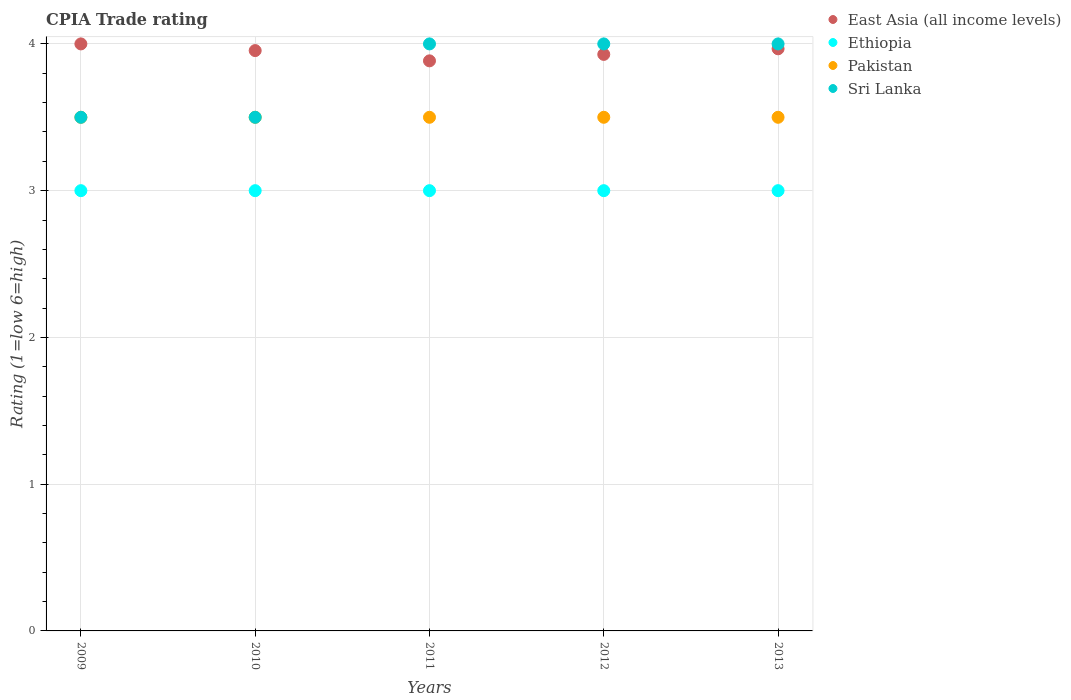Is the number of dotlines equal to the number of legend labels?
Offer a very short reply. Yes. Across all years, what is the maximum CPIA rating in Sri Lanka?
Provide a succinct answer. 4. Across all years, what is the minimum CPIA rating in East Asia (all income levels)?
Make the answer very short. 3.88. In which year was the CPIA rating in Pakistan minimum?
Provide a short and direct response. 2009. What is the total CPIA rating in East Asia (all income levels) in the graph?
Keep it short and to the point. 19.73. What is the difference between the CPIA rating in East Asia (all income levels) in 2010 and that in 2013?
Your answer should be very brief. -0.01. What is the difference between the CPIA rating in Pakistan in 2010 and the CPIA rating in Ethiopia in 2009?
Make the answer very short. 0.5. In the year 2012, what is the difference between the CPIA rating in Pakistan and CPIA rating in Sri Lanka?
Offer a very short reply. -0.5. In how many years, is the CPIA rating in East Asia (all income levels) greater than 1.2?
Provide a succinct answer. 5. What is the ratio of the CPIA rating in Ethiopia in 2010 to that in 2011?
Offer a terse response. 1. Is the CPIA rating in Ethiopia in 2012 less than that in 2013?
Give a very brief answer. No. What is the difference between the highest and the second highest CPIA rating in Sri Lanka?
Offer a terse response. 0. Is it the case that in every year, the sum of the CPIA rating in Ethiopia and CPIA rating in Pakistan  is greater than the sum of CPIA rating in East Asia (all income levels) and CPIA rating in Sri Lanka?
Your answer should be compact. No. Is it the case that in every year, the sum of the CPIA rating in Ethiopia and CPIA rating in East Asia (all income levels)  is greater than the CPIA rating in Sri Lanka?
Make the answer very short. Yes. Is the CPIA rating in Pakistan strictly greater than the CPIA rating in Ethiopia over the years?
Provide a succinct answer. Yes. Is the CPIA rating in East Asia (all income levels) strictly less than the CPIA rating in Pakistan over the years?
Ensure brevity in your answer.  No. How many years are there in the graph?
Ensure brevity in your answer.  5. Are the values on the major ticks of Y-axis written in scientific E-notation?
Offer a very short reply. No. Does the graph contain any zero values?
Offer a terse response. No. Does the graph contain grids?
Offer a terse response. Yes. Where does the legend appear in the graph?
Offer a terse response. Top right. What is the title of the graph?
Keep it short and to the point. CPIA Trade rating. What is the label or title of the X-axis?
Your response must be concise. Years. What is the Rating (1=low 6=high) of East Asia (all income levels) in 2009?
Provide a succinct answer. 4. What is the Rating (1=low 6=high) of Ethiopia in 2009?
Keep it short and to the point. 3. What is the Rating (1=low 6=high) of Pakistan in 2009?
Offer a very short reply. 3.5. What is the Rating (1=low 6=high) in East Asia (all income levels) in 2010?
Provide a succinct answer. 3.95. What is the Rating (1=low 6=high) in Ethiopia in 2010?
Keep it short and to the point. 3. What is the Rating (1=low 6=high) in Pakistan in 2010?
Provide a short and direct response. 3.5. What is the Rating (1=low 6=high) of Sri Lanka in 2010?
Provide a short and direct response. 3.5. What is the Rating (1=low 6=high) in East Asia (all income levels) in 2011?
Keep it short and to the point. 3.88. What is the Rating (1=low 6=high) of Pakistan in 2011?
Give a very brief answer. 3.5. What is the Rating (1=low 6=high) in East Asia (all income levels) in 2012?
Provide a short and direct response. 3.93. What is the Rating (1=low 6=high) of Ethiopia in 2012?
Give a very brief answer. 3. What is the Rating (1=low 6=high) in Sri Lanka in 2012?
Ensure brevity in your answer.  4. What is the Rating (1=low 6=high) in East Asia (all income levels) in 2013?
Offer a very short reply. 3.97. What is the Rating (1=low 6=high) in Ethiopia in 2013?
Give a very brief answer. 3. Across all years, what is the maximum Rating (1=low 6=high) in Ethiopia?
Your response must be concise. 3. Across all years, what is the maximum Rating (1=low 6=high) of Pakistan?
Provide a short and direct response. 3.5. Across all years, what is the minimum Rating (1=low 6=high) of East Asia (all income levels)?
Give a very brief answer. 3.88. Across all years, what is the minimum Rating (1=low 6=high) of Ethiopia?
Keep it short and to the point. 3. What is the total Rating (1=low 6=high) of East Asia (all income levels) in the graph?
Offer a terse response. 19.73. What is the total Rating (1=low 6=high) in Pakistan in the graph?
Offer a terse response. 17.5. What is the total Rating (1=low 6=high) of Sri Lanka in the graph?
Offer a very short reply. 19. What is the difference between the Rating (1=low 6=high) in East Asia (all income levels) in 2009 and that in 2010?
Give a very brief answer. 0.05. What is the difference between the Rating (1=low 6=high) of Ethiopia in 2009 and that in 2010?
Your answer should be compact. 0. What is the difference between the Rating (1=low 6=high) of Pakistan in 2009 and that in 2010?
Provide a short and direct response. 0. What is the difference between the Rating (1=low 6=high) in Sri Lanka in 2009 and that in 2010?
Ensure brevity in your answer.  0. What is the difference between the Rating (1=low 6=high) of East Asia (all income levels) in 2009 and that in 2011?
Provide a succinct answer. 0.12. What is the difference between the Rating (1=low 6=high) in Pakistan in 2009 and that in 2011?
Your answer should be very brief. 0. What is the difference between the Rating (1=low 6=high) of East Asia (all income levels) in 2009 and that in 2012?
Your response must be concise. 0.07. What is the difference between the Rating (1=low 6=high) in Sri Lanka in 2009 and that in 2012?
Give a very brief answer. -0.5. What is the difference between the Rating (1=low 6=high) in Ethiopia in 2009 and that in 2013?
Make the answer very short. 0. What is the difference between the Rating (1=low 6=high) of Pakistan in 2009 and that in 2013?
Your answer should be very brief. 0. What is the difference between the Rating (1=low 6=high) in East Asia (all income levels) in 2010 and that in 2011?
Your answer should be compact. 0.07. What is the difference between the Rating (1=low 6=high) of Ethiopia in 2010 and that in 2011?
Your response must be concise. 0. What is the difference between the Rating (1=low 6=high) in East Asia (all income levels) in 2010 and that in 2012?
Your answer should be compact. 0.03. What is the difference between the Rating (1=low 6=high) in Ethiopia in 2010 and that in 2012?
Provide a succinct answer. 0. What is the difference between the Rating (1=low 6=high) of Pakistan in 2010 and that in 2012?
Ensure brevity in your answer.  0. What is the difference between the Rating (1=low 6=high) of East Asia (all income levels) in 2010 and that in 2013?
Offer a terse response. -0.01. What is the difference between the Rating (1=low 6=high) of Pakistan in 2010 and that in 2013?
Provide a short and direct response. 0. What is the difference between the Rating (1=low 6=high) of East Asia (all income levels) in 2011 and that in 2012?
Your answer should be very brief. -0.04. What is the difference between the Rating (1=low 6=high) of Pakistan in 2011 and that in 2012?
Ensure brevity in your answer.  0. What is the difference between the Rating (1=low 6=high) in Sri Lanka in 2011 and that in 2012?
Give a very brief answer. 0. What is the difference between the Rating (1=low 6=high) in East Asia (all income levels) in 2011 and that in 2013?
Provide a succinct answer. -0.08. What is the difference between the Rating (1=low 6=high) of East Asia (all income levels) in 2012 and that in 2013?
Offer a terse response. -0.04. What is the difference between the Rating (1=low 6=high) of Pakistan in 2012 and that in 2013?
Keep it short and to the point. 0. What is the difference between the Rating (1=low 6=high) in Sri Lanka in 2012 and that in 2013?
Provide a short and direct response. 0. What is the difference between the Rating (1=low 6=high) in East Asia (all income levels) in 2009 and the Rating (1=low 6=high) in Ethiopia in 2010?
Provide a short and direct response. 1. What is the difference between the Rating (1=low 6=high) of East Asia (all income levels) in 2009 and the Rating (1=low 6=high) of Pakistan in 2010?
Make the answer very short. 0.5. What is the difference between the Rating (1=low 6=high) of Ethiopia in 2009 and the Rating (1=low 6=high) of Sri Lanka in 2010?
Provide a short and direct response. -0.5. What is the difference between the Rating (1=low 6=high) of Pakistan in 2009 and the Rating (1=low 6=high) of Sri Lanka in 2010?
Offer a very short reply. 0. What is the difference between the Rating (1=low 6=high) in Ethiopia in 2009 and the Rating (1=low 6=high) in Sri Lanka in 2011?
Give a very brief answer. -1. What is the difference between the Rating (1=low 6=high) of Pakistan in 2009 and the Rating (1=low 6=high) of Sri Lanka in 2011?
Offer a terse response. -0.5. What is the difference between the Rating (1=low 6=high) of Ethiopia in 2009 and the Rating (1=low 6=high) of Pakistan in 2012?
Ensure brevity in your answer.  -0.5. What is the difference between the Rating (1=low 6=high) of Ethiopia in 2009 and the Rating (1=low 6=high) of Sri Lanka in 2012?
Provide a short and direct response. -1. What is the difference between the Rating (1=low 6=high) in Pakistan in 2009 and the Rating (1=low 6=high) in Sri Lanka in 2012?
Make the answer very short. -0.5. What is the difference between the Rating (1=low 6=high) of East Asia (all income levels) in 2009 and the Rating (1=low 6=high) of Ethiopia in 2013?
Your response must be concise. 1. What is the difference between the Rating (1=low 6=high) in East Asia (all income levels) in 2009 and the Rating (1=low 6=high) in Pakistan in 2013?
Ensure brevity in your answer.  0.5. What is the difference between the Rating (1=low 6=high) in East Asia (all income levels) in 2009 and the Rating (1=low 6=high) in Sri Lanka in 2013?
Your answer should be very brief. 0. What is the difference between the Rating (1=low 6=high) of East Asia (all income levels) in 2010 and the Rating (1=low 6=high) of Ethiopia in 2011?
Offer a terse response. 0.95. What is the difference between the Rating (1=low 6=high) of East Asia (all income levels) in 2010 and the Rating (1=low 6=high) of Pakistan in 2011?
Keep it short and to the point. 0.45. What is the difference between the Rating (1=low 6=high) of East Asia (all income levels) in 2010 and the Rating (1=low 6=high) of Sri Lanka in 2011?
Make the answer very short. -0.05. What is the difference between the Rating (1=low 6=high) in Ethiopia in 2010 and the Rating (1=low 6=high) in Pakistan in 2011?
Offer a very short reply. -0.5. What is the difference between the Rating (1=low 6=high) of East Asia (all income levels) in 2010 and the Rating (1=low 6=high) of Ethiopia in 2012?
Your response must be concise. 0.95. What is the difference between the Rating (1=low 6=high) of East Asia (all income levels) in 2010 and the Rating (1=low 6=high) of Pakistan in 2012?
Your response must be concise. 0.45. What is the difference between the Rating (1=low 6=high) of East Asia (all income levels) in 2010 and the Rating (1=low 6=high) of Sri Lanka in 2012?
Offer a terse response. -0.05. What is the difference between the Rating (1=low 6=high) of Ethiopia in 2010 and the Rating (1=low 6=high) of Sri Lanka in 2012?
Give a very brief answer. -1. What is the difference between the Rating (1=low 6=high) of Pakistan in 2010 and the Rating (1=low 6=high) of Sri Lanka in 2012?
Ensure brevity in your answer.  -0.5. What is the difference between the Rating (1=low 6=high) in East Asia (all income levels) in 2010 and the Rating (1=low 6=high) in Ethiopia in 2013?
Offer a very short reply. 0.95. What is the difference between the Rating (1=low 6=high) in East Asia (all income levels) in 2010 and the Rating (1=low 6=high) in Pakistan in 2013?
Your response must be concise. 0.45. What is the difference between the Rating (1=low 6=high) of East Asia (all income levels) in 2010 and the Rating (1=low 6=high) of Sri Lanka in 2013?
Give a very brief answer. -0.05. What is the difference between the Rating (1=low 6=high) of Ethiopia in 2010 and the Rating (1=low 6=high) of Sri Lanka in 2013?
Ensure brevity in your answer.  -1. What is the difference between the Rating (1=low 6=high) of East Asia (all income levels) in 2011 and the Rating (1=low 6=high) of Ethiopia in 2012?
Keep it short and to the point. 0.88. What is the difference between the Rating (1=low 6=high) in East Asia (all income levels) in 2011 and the Rating (1=low 6=high) in Pakistan in 2012?
Keep it short and to the point. 0.38. What is the difference between the Rating (1=low 6=high) in East Asia (all income levels) in 2011 and the Rating (1=low 6=high) in Sri Lanka in 2012?
Make the answer very short. -0.12. What is the difference between the Rating (1=low 6=high) of East Asia (all income levels) in 2011 and the Rating (1=low 6=high) of Ethiopia in 2013?
Provide a short and direct response. 0.88. What is the difference between the Rating (1=low 6=high) in East Asia (all income levels) in 2011 and the Rating (1=low 6=high) in Pakistan in 2013?
Provide a succinct answer. 0.38. What is the difference between the Rating (1=low 6=high) in East Asia (all income levels) in 2011 and the Rating (1=low 6=high) in Sri Lanka in 2013?
Your answer should be compact. -0.12. What is the difference between the Rating (1=low 6=high) of Ethiopia in 2011 and the Rating (1=low 6=high) of Pakistan in 2013?
Offer a very short reply. -0.5. What is the difference between the Rating (1=low 6=high) in Ethiopia in 2011 and the Rating (1=low 6=high) in Sri Lanka in 2013?
Provide a short and direct response. -1. What is the difference between the Rating (1=low 6=high) in Pakistan in 2011 and the Rating (1=low 6=high) in Sri Lanka in 2013?
Give a very brief answer. -0.5. What is the difference between the Rating (1=low 6=high) of East Asia (all income levels) in 2012 and the Rating (1=low 6=high) of Ethiopia in 2013?
Your response must be concise. 0.93. What is the difference between the Rating (1=low 6=high) of East Asia (all income levels) in 2012 and the Rating (1=low 6=high) of Pakistan in 2013?
Provide a succinct answer. 0.43. What is the difference between the Rating (1=low 6=high) of East Asia (all income levels) in 2012 and the Rating (1=low 6=high) of Sri Lanka in 2013?
Give a very brief answer. -0.07. What is the difference between the Rating (1=low 6=high) in Ethiopia in 2012 and the Rating (1=low 6=high) in Sri Lanka in 2013?
Your answer should be very brief. -1. What is the average Rating (1=low 6=high) in East Asia (all income levels) per year?
Keep it short and to the point. 3.95. What is the average Rating (1=low 6=high) in Ethiopia per year?
Offer a terse response. 3. What is the average Rating (1=low 6=high) of Pakistan per year?
Keep it short and to the point. 3.5. In the year 2009, what is the difference between the Rating (1=low 6=high) in East Asia (all income levels) and Rating (1=low 6=high) in Pakistan?
Make the answer very short. 0.5. In the year 2009, what is the difference between the Rating (1=low 6=high) in East Asia (all income levels) and Rating (1=low 6=high) in Sri Lanka?
Offer a very short reply. 0.5. In the year 2009, what is the difference between the Rating (1=low 6=high) of Ethiopia and Rating (1=low 6=high) of Pakistan?
Provide a short and direct response. -0.5. In the year 2009, what is the difference between the Rating (1=low 6=high) of Pakistan and Rating (1=low 6=high) of Sri Lanka?
Provide a short and direct response. 0. In the year 2010, what is the difference between the Rating (1=low 6=high) of East Asia (all income levels) and Rating (1=low 6=high) of Ethiopia?
Offer a very short reply. 0.95. In the year 2010, what is the difference between the Rating (1=low 6=high) in East Asia (all income levels) and Rating (1=low 6=high) in Pakistan?
Offer a terse response. 0.45. In the year 2010, what is the difference between the Rating (1=low 6=high) of East Asia (all income levels) and Rating (1=low 6=high) of Sri Lanka?
Offer a terse response. 0.45. In the year 2011, what is the difference between the Rating (1=low 6=high) of East Asia (all income levels) and Rating (1=low 6=high) of Ethiopia?
Offer a terse response. 0.88. In the year 2011, what is the difference between the Rating (1=low 6=high) in East Asia (all income levels) and Rating (1=low 6=high) in Pakistan?
Your answer should be compact. 0.38. In the year 2011, what is the difference between the Rating (1=low 6=high) in East Asia (all income levels) and Rating (1=low 6=high) in Sri Lanka?
Give a very brief answer. -0.12. In the year 2011, what is the difference between the Rating (1=low 6=high) in Ethiopia and Rating (1=low 6=high) in Pakistan?
Provide a short and direct response. -0.5. In the year 2011, what is the difference between the Rating (1=low 6=high) of Pakistan and Rating (1=low 6=high) of Sri Lanka?
Make the answer very short. -0.5. In the year 2012, what is the difference between the Rating (1=low 6=high) in East Asia (all income levels) and Rating (1=low 6=high) in Ethiopia?
Give a very brief answer. 0.93. In the year 2012, what is the difference between the Rating (1=low 6=high) of East Asia (all income levels) and Rating (1=low 6=high) of Pakistan?
Offer a terse response. 0.43. In the year 2012, what is the difference between the Rating (1=low 6=high) in East Asia (all income levels) and Rating (1=low 6=high) in Sri Lanka?
Your answer should be very brief. -0.07. In the year 2012, what is the difference between the Rating (1=low 6=high) of Ethiopia and Rating (1=low 6=high) of Sri Lanka?
Provide a succinct answer. -1. In the year 2013, what is the difference between the Rating (1=low 6=high) in East Asia (all income levels) and Rating (1=low 6=high) in Ethiopia?
Provide a succinct answer. 0.97. In the year 2013, what is the difference between the Rating (1=low 6=high) of East Asia (all income levels) and Rating (1=low 6=high) of Pakistan?
Keep it short and to the point. 0.47. In the year 2013, what is the difference between the Rating (1=low 6=high) in East Asia (all income levels) and Rating (1=low 6=high) in Sri Lanka?
Provide a succinct answer. -0.03. In the year 2013, what is the difference between the Rating (1=low 6=high) of Ethiopia and Rating (1=low 6=high) of Sri Lanka?
Provide a short and direct response. -1. What is the ratio of the Rating (1=low 6=high) in East Asia (all income levels) in 2009 to that in 2010?
Your answer should be compact. 1.01. What is the ratio of the Rating (1=low 6=high) in Ethiopia in 2009 to that in 2010?
Keep it short and to the point. 1. What is the ratio of the Rating (1=low 6=high) in East Asia (all income levels) in 2009 to that in 2011?
Keep it short and to the point. 1.03. What is the ratio of the Rating (1=low 6=high) in Ethiopia in 2009 to that in 2011?
Your answer should be compact. 1. What is the ratio of the Rating (1=low 6=high) in Pakistan in 2009 to that in 2011?
Your answer should be compact. 1. What is the ratio of the Rating (1=low 6=high) in Sri Lanka in 2009 to that in 2011?
Your answer should be compact. 0.88. What is the ratio of the Rating (1=low 6=high) of East Asia (all income levels) in 2009 to that in 2012?
Your response must be concise. 1.02. What is the ratio of the Rating (1=low 6=high) in Pakistan in 2009 to that in 2012?
Make the answer very short. 1. What is the ratio of the Rating (1=low 6=high) in East Asia (all income levels) in 2009 to that in 2013?
Give a very brief answer. 1.01. What is the ratio of the Rating (1=low 6=high) of Pakistan in 2009 to that in 2013?
Give a very brief answer. 1. What is the ratio of the Rating (1=low 6=high) in Sri Lanka in 2009 to that in 2013?
Keep it short and to the point. 0.88. What is the ratio of the Rating (1=low 6=high) of Sri Lanka in 2010 to that in 2011?
Provide a short and direct response. 0.88. What is the ratio of the Rating (1=low 6=high) in East Asia (all income levels) in 2010 to that in 2012?
Offer a very short reply. 1.01. What is the ratio of the Rating (1=low 6=high) in Sri Lanka in 2010 to that in 2012?
Give a very brief answer. 0.88. What is the ratio of the Rating (1=low 6=high) of East Asia (all income levels) in 2010 to that in 2013?
Provide a short and direct response. 1. What is the ratio of the Rating (1=low 6=high) of Pakistan in 2010 to that in 2013?
Provide a short and direct response. 1. What is the ratio of the Rating (1=low 6=high) of Ethiopia in 2011 to that in 2012?
Provide a succinct answer. 1. What is the ratio of the Rating (1=low 6=high) in Sri Lanka in 2011 to that in 2012?
Ensure brevity in your answer.  1. What is the ratio of the Rating (1=low 6=high) of East Asia (all income levels) in 2011 to that in 2013?
Give a very brief answer. 0.98. What is the ratio of the Rating (1=low 6=high) of Pakistan in 2011 to that in 2013?
Provide a short and direct response. 1. What is the ratio of the Rating (1=low 6=high) of East Asia (all income levels) in 2012 to that in 2013?
Your answer should be very brief. 0.99. What is the ratio of the Rating (1=low 6=high) of Ethiopia in 2012 to that in 2013?
Offer a very short reply. 1. What is the difference between the highest and the second highest Rating (1=low 6=high) of East Asia (all income levels)?
Keep it short and to the point. 0.03. What is the difference between the highest and the second highest Rating (1=low 6=high) of Ethiopia?
Make the answer very short. 0. What is the difference between the highest and the second highest Rating (1=low 6=high) of Pakistan?
Offer a very short reply. 0. What is the difference between the highest and the second highest Rating (1=low 6=high) in Sri Lanka?
Your answer should be very brief. 0. What is the difference between the highest and the lowest Rating (1=low 6=high) of East Asia (all income levels)?
Give a very brief answer. 0.12. What is the difference between the highest and the lowest Rating (1=low 6=high) in Ethiopia?
Offer a very short reply. 0. What is the difference between the highest and the lowest Rating (1=low 6=high) of Pakistan?
Ensure brevity in your answer.  0. 